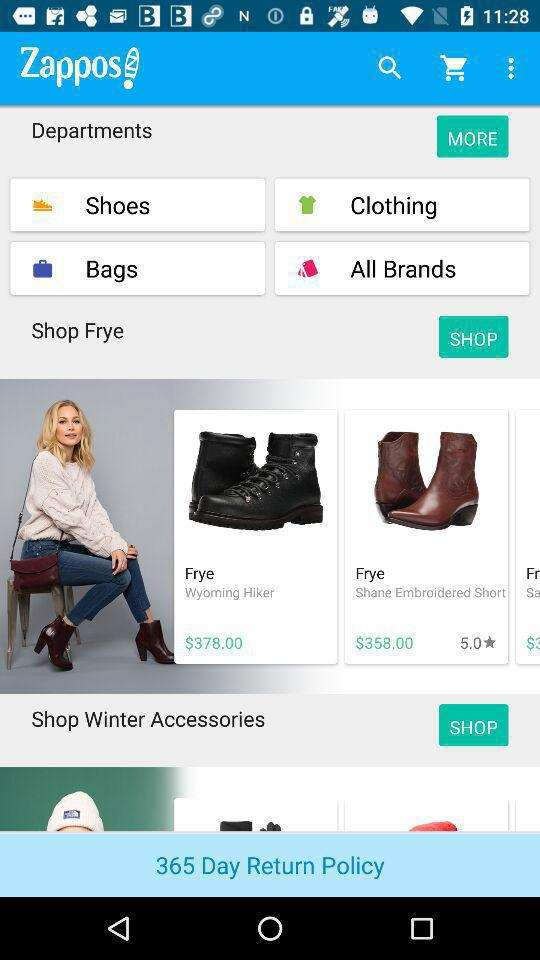How much is the total price of the items in the 'Shop Frye' section?
Answer the question using a single word or phrase. $736.00 